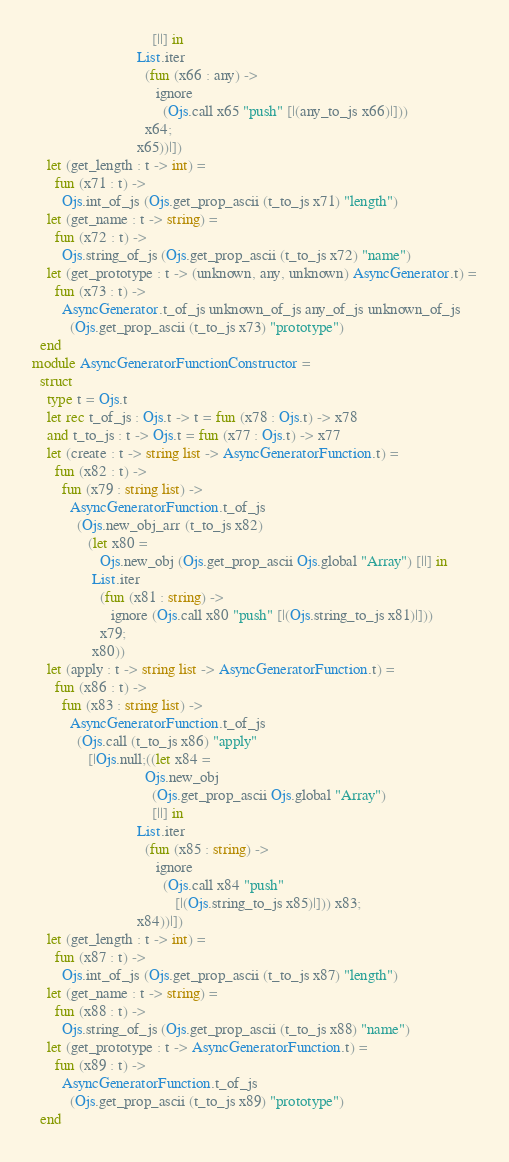<code> <loc_0><loc_0><loc_500><loc_500><_OCaml_>                                [||] in
                            List.iter
                              (fun (x66 : any) ->
                                 ignore
                                   (Ojs.call x65 "push" [|(any_to_js x66)|]))
                              x64;
                            x65))|])
    let (get_length : t -> int) =
      fun (x71 : t) ->
        Ojs.int_of_js (Ojs.get_prop_ascii (t_to_js x71) "length")
    let (get_name : t -> string) =
      fun (x72 : t) ->
        Ojs.string_of_js (Ojs.get_prop_ascii (t_to_js x72) "name")
    let (get_prototype : t -> (unknown, any, unknown) AsyncGenerator.t) =
      fun (x73 : t) ->
        AsyncGenerator.t_of_js unknown_of_js any_of_js unknown_of_js
          (Ojs.get_prop_ascii (t_to_js x73) "prototype")
  end
module AsyncGeneratorFunctionConstructor =
  struct
    type t = Ojs.t
    let rec t_of_js : Ojs.t -> t = fun (x78 : Ojs.t) -> x78
    and t_to_js : t -> Ojs.t = fun (x77 : Ojs.t) -> x77
    let (create : t -> string list -> AsyncGeneratorFunction.t) =
      fun (x82 : t) ->
        fun (x79 : string list) ->
          AsyncGeneratorFunction.t_of_js
            (Ojs.new_obj_arr (t_to_js x82)
               (let x80 =
                  Ojs.new_obj (Ojs.get_prop_ascii Ojs.global "Array") [||] in
                List.iter
                  (fun (x81 : string) ->
                     ignore (Ojs.call x80 "push" [|(Ojs.string_to_js x81)|]))
                  x79;
                x80))
    let (apply : t -> string list -> AsyncGeneratorFunction.t) =
      fun (x86 : t) ->
        fun (x83 : string list) ->
          AsyncGeneratorFunction.t_of_js
            (Ojs.call (t_to_js x86) "apply"
               [|Ojs.null;((let x84 =
                              Ojs.new_obj
                                (Ojs.get_prop_ascii Ojs.global "Array") 
                                [||] in
                            List.iter
                              (fun (x85 : string) ->
                                 ignore
                                   (Ojs.call x84 "push"
                                      [|(Ojs.string_to_js x85)|])) x83;
                            x84))|])
    let (get_length : t -> int) =
      fun (x87 : t) ->
        Ojs.int_of_js (Ojs.get_prop_ascii (t_to_js x87) "length")
    let (get_name : t -> string) =
      fun (x88 : t) ->
        Ojs.string_of_js (Ojs.get_prop_ascii (t_to_js x88) "name")
    let (get_prototype : t -> AsyncGeneratorFunction.t) =
      fun (x89 : t) ->
        AsyncGeneratorFunction.t_of_js
          (Ojs.get_prop_ascii (t_to_js x89) "prototype")
  end
</code> 